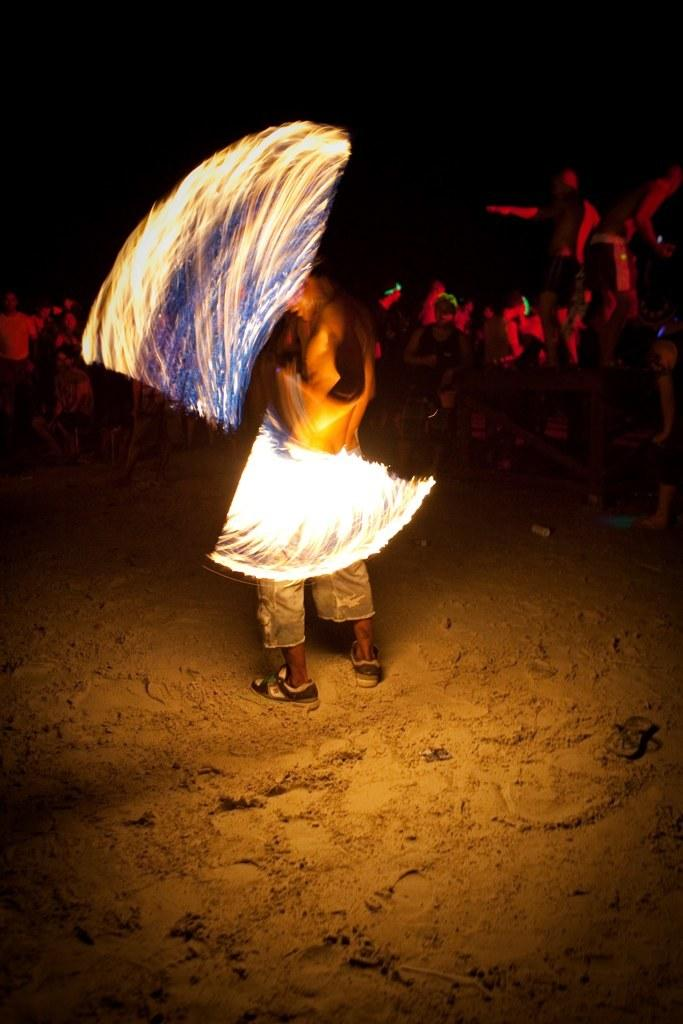What is the main element in the image? There is fire in the image. Where is the person located in the image? The person is on the sand. What can be seen in the background of the image? There is a group of people in the background, and the background has a dark view. What type of star can be seen in the image? There is no star visible in the image. What action is the person performing in the image? The provided facts do not specify any action being performed by the person in the image. 